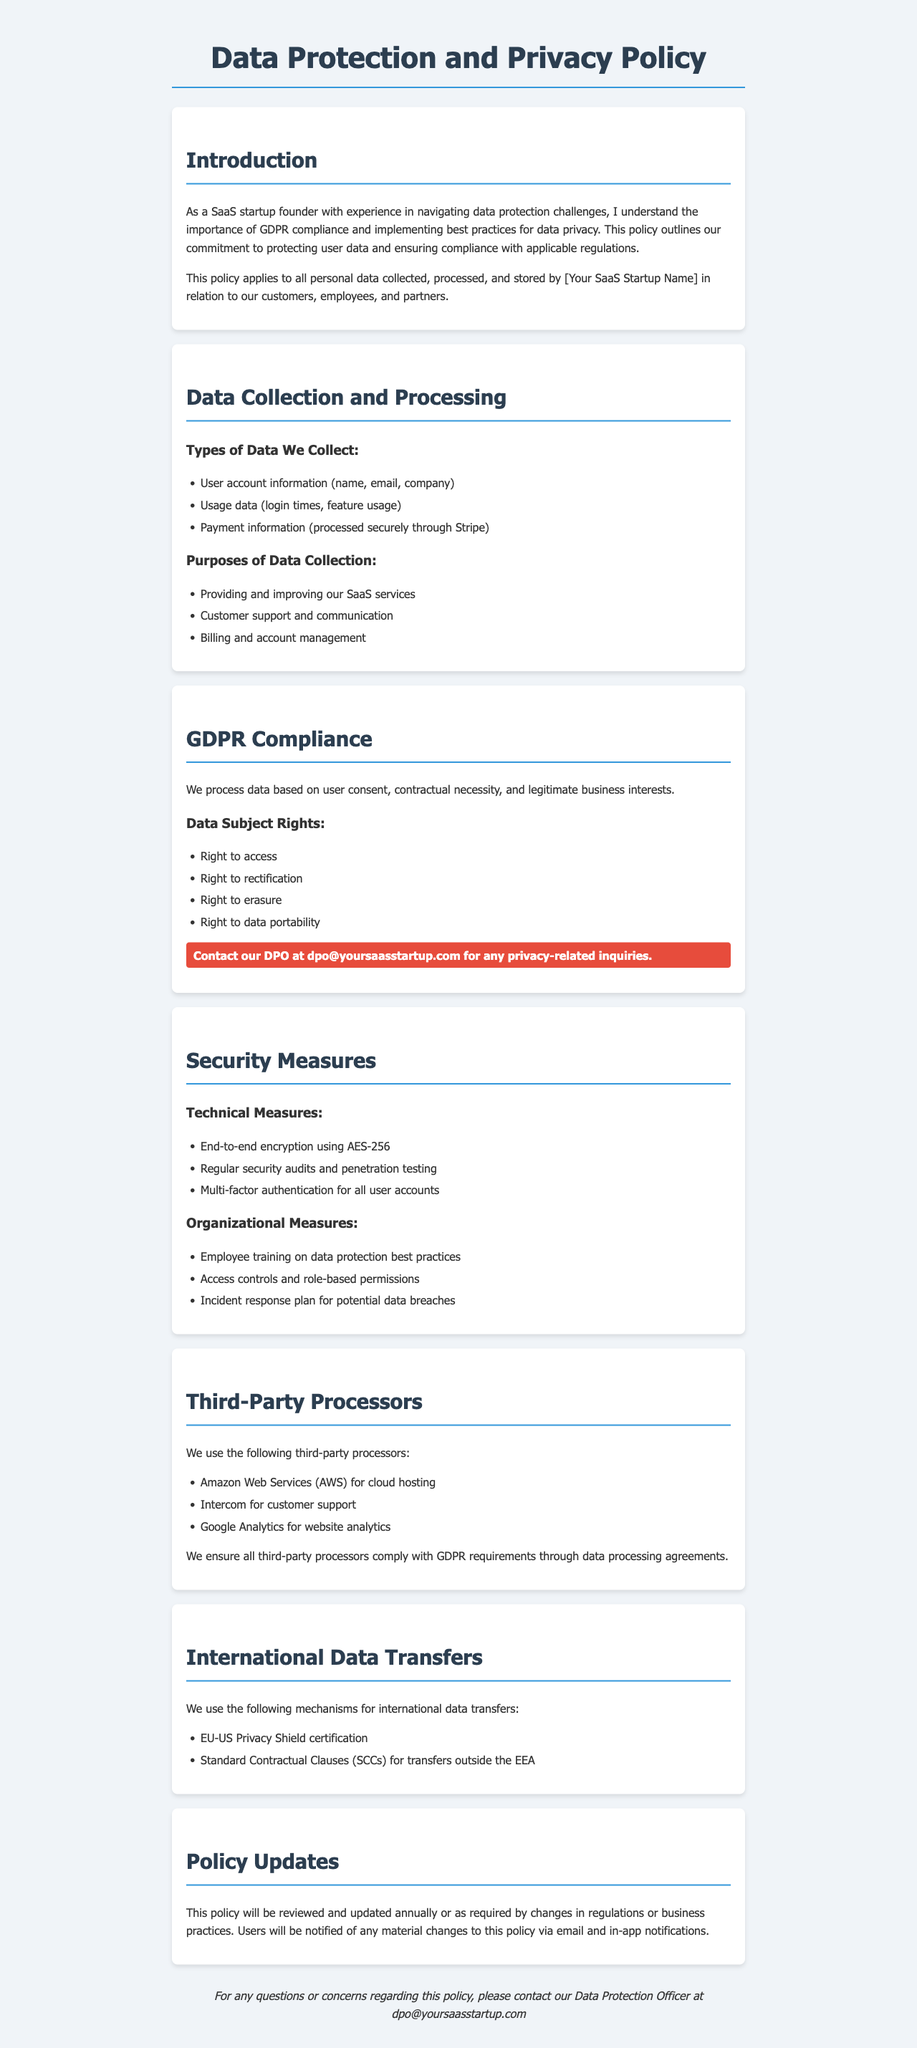What is the purpose of data collection? The purpose of data collection is outlined in the document, specifying the main reasons for collecting user data.
Answer: Providing and improving our SaaS services Who should be contacted for privacy-related inquiries? The document specifies a contact point for privacy-related inquiries, which is important for users to note.
Answer: dpo@yoursaasstartup.com What type of data is processed securely through Stripe? The document mentions the specific data that is processed with a focus on security through a popular payment processor.
Answer: Payment information What rights do data subjects have? The document lists various rights that data subjects are entitled to under GDPR, which are key for compliance.
Answer: Right to access, Right to rectification, Right to erasure, Right to data portability How often will the policy be reviewed and updated? The document indicates the review frequency of the policy, which reflects the organization's commitment to compliance.
Answer: Annually Which third-party processor is used for cloud hosting? The document lists third-party processors and includes the specific provider used for cloud services.
Answer: Amazon Web Services (AWS) What type of encryption is used for data security? The document outlines technical security measures, including the specific type of encryption employed to protect data.
Answer: AES-256 What is the highlight about contacting the DPO? The document emphasizes a particular note regarding contacting the Data Protection Officer, important for user awareness.
Answer: Contact our DPO at dpo@yoursaasstartup.com for any privacy-related inquiries 